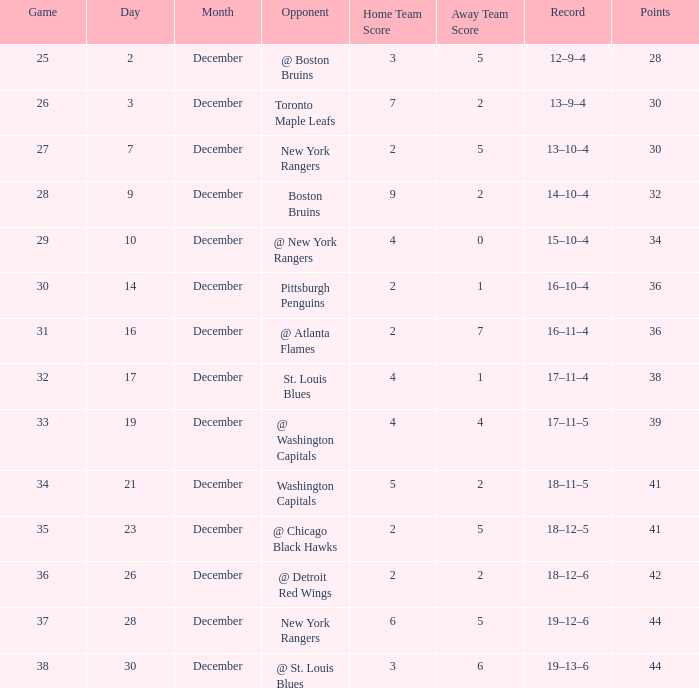Could you parse the entire table as a dict? {'header': ['Game', 'Day', 'Month', 'Opponent', 'Home Team Score', 'Away Team Score', 'Record', 'Points'], 'rows': [['25', '2', 'December', '@ Boston Bruins', '3', '5', '12–9–4', '28'], ['26', '3', 'December', 'Toronto Maple Leafs', '7', '2', '13–9–4', '30'], ['27', '7', 'December', 'New York Rangers', '2', '5', '13–10–4', '30'], ['28', '9', 'December', 'Boston Bruins', '9', '2', '14–10–4', '32'], ['29', '10', 'December', '@ New York Rangers', '4', '0', '15–10–4', '34'], ['30', '14', 'December', 'Pittsburgh Penguins', '2', '1', '16–10–4', '36'], ['31', '16', 'December', '@ Atlanta Flames', '2', '7', '16–11–4', '36'], ['32', '17', 'December', 'St. Louis Blues', '4', '1', '17–11–4', '38'], ['33', '19', 'December', '@ Washington Capitals', '4', '4', '17–11–5', '39'], ['34', '21', 'December', 'Washington Capitals', '5', '2', '18–11–5', '41'], ['35', '23', 'December', '@ Chicago Black Hawks', '2', '5', '18–12–5', '41'], ['36', '26', 'December', '@ Detroit Red Wings', '2', '2', '18–12–6', '42'], ['37', '28', 'December', 'New York Rangers', '6', '5', '19–12–6', '44'], ['38', '30', 'December', '@ St. Louis Blues', '3', '6', '19–13–6', '44']]} What score possesses a record of 18-11-5? 5–2. 